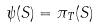<formula> <loc_0><loc_0><loc_500><loc_500>\psi ( S ) = \pi _ { T } ( S )</formula> 